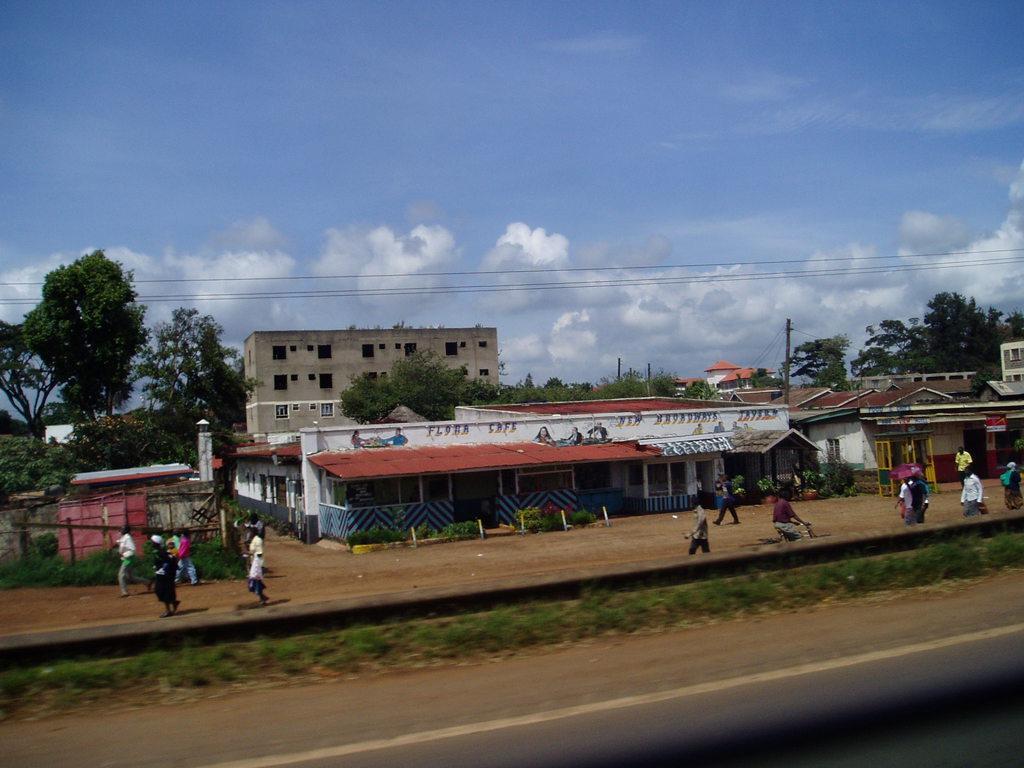Could you give a brief overview of what you see in this image? In this image there is grass on the ground. In the background there are persons walking and standing, there are buildings and trees and the sky is cloudy and there are poles. 